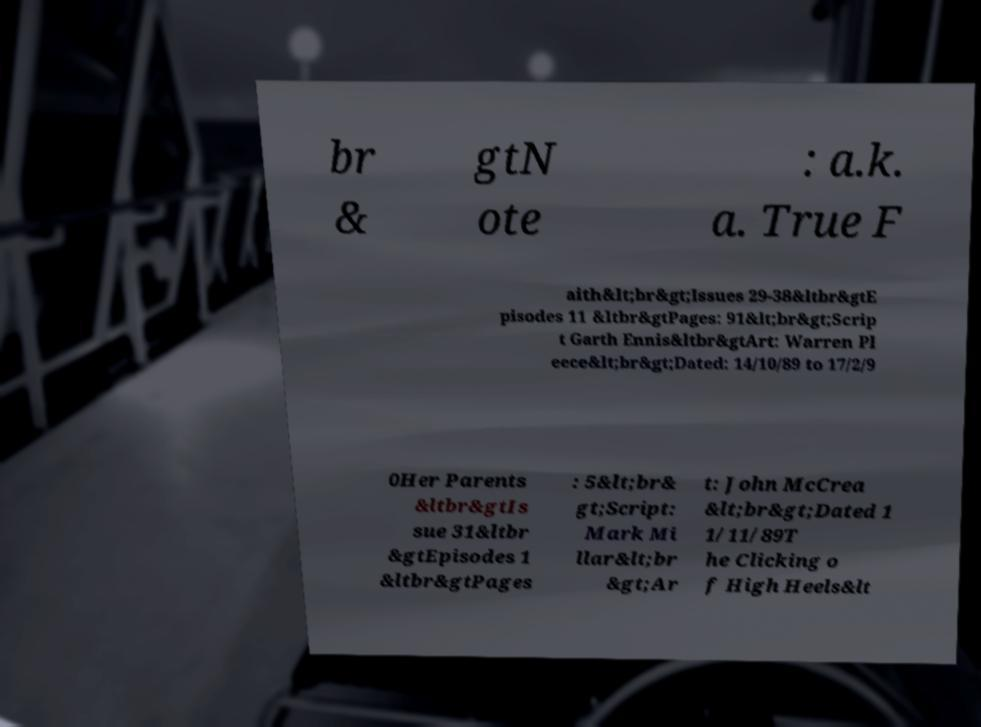Can you read and provide the text displayed in the image?This photo seems to have some interesting text. Can you extract and type it out for me? br & gtN ote : a.k. a. True F aith&lt;br&gt;Issues 29-38&ltbr&gtE pisodes 11 &ltbr&gtPages: 91&lt;br&gt;Scrip t Garth Ennis&ltbr&gtArt: Warren Pl eece&lt;br&gt;Dated: 14/10/89 to 17/2/9 0Her Parents &ltbr&gtIs sue 31&ltbr &gtEpisodes 1 &ltbr&gtPages : 5&lt;br& gt;Script: Mark Mi llar&lt;br &gt;Ar t: John McCrea &lt;br&gt;Dated 1 1/11/89T he Clicking o f High Heels&lt 